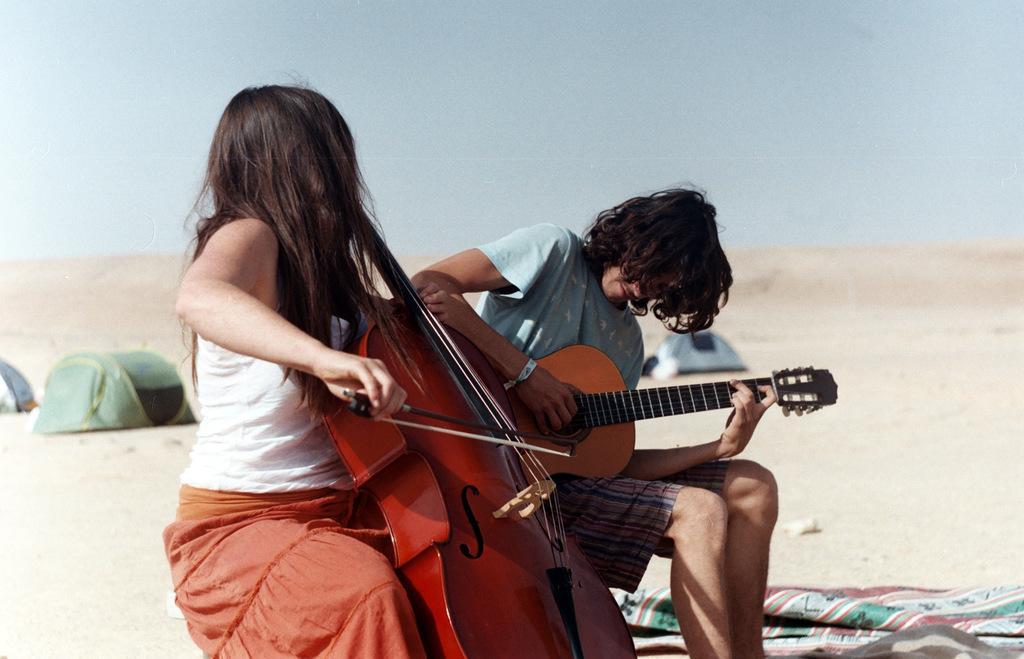Can you describe this image briefly? In this picture i could see two persons holding musical instruments on left a violin and to the right a guitar, is sitting on the chair in the sand. In the background i could see small tents all around. 